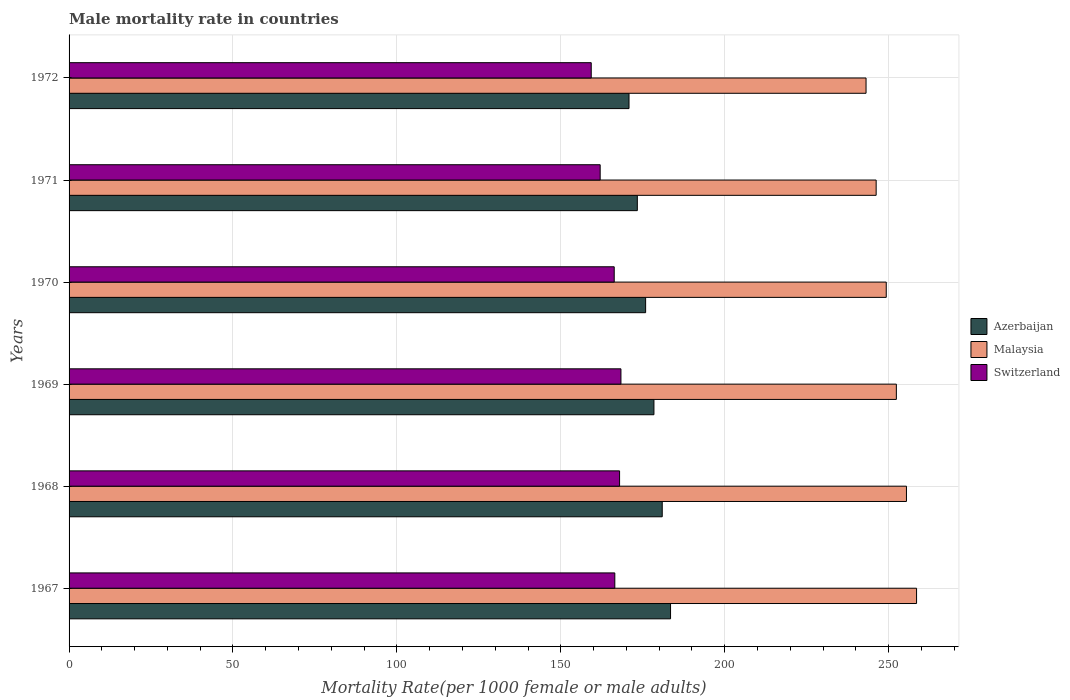How many different coloured bars are there?
Your answer should be very brief. 3. How many groups of bars are there?
Ensure brevity in your answer.  6. Are the number of bars per tick equal to the number of legend labels?
Provide a short and direct response. Yes. How many bars are there on the 5th tick from the top?
Your response must be concise. 3. What is the label of the 5th group of bars from the top?
Give a very brief answer. 1968. In how many cases, is the number of bars for a given year not equal to the number of legend labels?
Your answer should be compact. 0. What is the male mortality rate in Malaysia in 1972?
Keep it short and to the point. 243.12. Across all years, what is the maximum male mortality rate in Azerbaijan?
Make the answer very short. 183.47. Across all years, what is the minimum male mortality rate in Azerbaijan?
Offer a terse response. 170.81. In which year was the male mortality rate in Malaysia maximum?
Keep it short and to the point. 1967. What is the total male mortality rate in Malaysia in the graph?
Provide a succinct answer. 1504.91. What is the difference between the male mortality rate in Switzerland in 1970 and that in 1971?
Your answer should be compact. 4.28. What is the difference between the male mortality rate in Switzerland in 1971 and the male mortality rate in Malaysia in 1967?
Offer a very short reply. -96.51. What is the average male mortality rate in Malaysia per year?
Make the answer very short. 250.82. In the year 1970, what is the difference between the male mortality rate in Switzerland and male mortality rate in Azerbaijan?
Keep it short and to the point. -9.58. In how many years, is the male mortality rate in Malaysia greater than 30 ?
Make the answer very short. 6. What is the ratio of the male mortality rate in Azerbaijan in 1967 to that in 1970?
Make the answer very short. 1.04. Is the difference between the male mortality rate in Switzerland in 1968 and 1969 greater than the difference between the male mortality rate in Azerbaijan in 1968 and 1969?
Give a very brief answer. No. What is the difference between the highest and the second highest male mortality rate in Malaysia?
Make the answer very short. 3.08. What is the difference between the highest and the lowest male mortality rate in Malaysia?
Keep it short and to the point. 15.41. What does the 3rd bar from the top in 1968 represents?
Your answer should be compact. Azerbaijan. What does the 3rd bar from the bottom in 1970 represents?
Your response must be concise. Switzerland. Are all the bars in the graph horizontal?
Your response must be concise. Yes. How many years are there in the graph?
Make the answer very short. 6. Does the graph contain any zero values?
Your answer should be very brief. No. How are the legend labels stacked?
Your answer should be very brief. Vertical. What is the title of the graph?
Your answer should be very brief. Male mortality rate in countries. What is the label or title of the X-axis?
Provide a short and direct response. Mortality Rate(per 1000 female or male adults). What is the label or title of the Y-axis?
Provide a short and direct response. Years. What is the Mortality Rate(per 1000 female or male adults) in Azerbaijan in 1967?
Make the answer very short. 183.47. What is the Mortality Rate(per 1000 female or male adults) of Malaysia in 1967?
Ensure brevity in your answer.  258.52. What is the Mortality Rate(per 1000 female or male adults) in Switzerland in 1967?
Provide a succinct answer. 166.48. What is the Mortality Rate(per 1000 female or male adults) in Azerbaijan in 1968?
Give a very brief answer. 180.94. What is the Mortality Rate(per 1000 female or male adults) in Malaysia in 1968?
Keep it short and to the point. 255.44. What is the Mortality Rate(per 1000 female or male adults) of Switzerland in 1968?
Make the answer very short. 167.93. What is the Mortality Rate(per 1000 female or male adults) in Azerbaijan in 1969?
Ensure brevity in your answer.  178.41. What is the Mortality Rate(per 1000 female or male adults) of Malaysia in 1969?
Offer a very short reply. 252.36. What is the Mortality Rate(per 1000 female or male adults) in Switzerland in 1969?
Provide a succinct answer. 168.34. What is the Mortality Rate(per 1000 female or male adults) in Azerbaijan in 1970?
Offer a terse response. 175.88. What is the Mortality Rate(per 1000 female or male adults) in Malaysia in 1970?
Your response must be concise. 249.28. What is the Mortality Rate(per 1000 female or male adults) in Switzerland in 1970?
Provide a succinct answer. 166.29. What is the Mortality Rate(per 1000 female or male adults) of Azerbaijan in 1971?
Your response must be concise. 173.34. What is the Mortality Rate(per 1000 female or male adults) of Malaysia in 1971?
Provide a short and direct response. 246.2. What is the Mortality Rate(per 1000 female or male adults) of Switzerland in 1971?
Offer a very short reply. 162.01. What is the Mortality Rate(per 1000 female or male adults) of Azerbaijan in 1972?
Your answer should be compact. 170.81. What is the Mortality Rate(per 1000 female or male adults) in Malaysia in 1972?
Make the answer very short. 243.12. What is the Mortality Rate(per 1000 female or male adults) in Switzerland in 1972?
Your answer should be very brief. 159.28. Across all years, what is the maximum Mortality Rate(per 1000 female or male adults) of Azerbaijan?
Offer a terse response. 183.47. Across all years, what is the maximum Mortality Rate(per 1000 female or male adults) of Malaysia?
Ensure brevity in your answer.  258.52. Across all years, what is the maximum Mortality Rate(per 1000 female or male adults) in Switzerland?
Provide a succinct answer. 168.34. Across all years, what is the minimum Mortality Rate(per 1000 female or male adults) of Azerbaijan?
Provide a succinct answer. 170.81. Across all years, what is the minimum Mortality Rate(per 1000 female or male adults) in Malaysia?
Offer a very short reply. 243.12. Across all years, what is the minimum Mortality Rate(per 1000 female or male adults) of Switzerland?
Ensure brevity in your answer.  159.28. What is the total Mortality Rate(per 1000 female or male adults) in Azerbaijan in the graph?
Your response must be concise. 1062.85. What is the total Mortality Rate(per 1000 female or male adults) in Malaysia in the graph?
Keep it short and to the point. 1504.91. What is the total Mortality Rate(per 1000 female or male adults) of Switzerland in the graph?
Your answer should be very brief. 990.34. What is the difference between the Mortality Rate(per 1000 female or male adults) of Azerbaijan in 1967 and that in 1968?
Keep it short and to the point. 2.53. What is the difference between the Mortality Rate(per 1000 female or male adults) in Malaysia in 1967 and that in 1968?
Keep it short and to the point. 3.08. What is the difference between the Mortality Rate(per 1000 female or male adults) of Switzerland in 1967 and that in 1968?
Provide a succinct answer. -1.45. What is the difference between the Mortality Rate(per 1000 female or male adults) of Azerbaijan in 1967 and that in 1969?
Offer a terse response. 5.07. What is the difference between the Mortality Rate(per 1000 female or male adults) in Malaysia in 1967 and that in 1969?
Provide a short and direct response. 6.16. What is the difference between the Mortality Rate(per 1000 female or male adults) of Switzerland in 1967 and that in 1969?
Your answer should be very brief. -1.87. What is the difference between the Mortality Rate(per 1000 female or male adults) in Azerbaijan in 1967 and that in 1970?
Your response must be concise. 7.6. What is the difference between the Mortality Rate(per 1000 female or male adults) in Malaysia in 1967 and that in 1970?
Make the answer very short. 9.24. What is the difference between the Mortality Rate(per 1000 female or male adults) in Switzerland in 1967 and that in 1970?
Your response must be concise. 0.18. What is the difference between the Mortality Rate(per 1000 female or male adults) in Azerbaijan in 1967 and that in 1971?
Make the answer very short. 10.13. What is the difference between the Mortality Rate(per 1000 female or male adults) of Malaysia in 1967 and that in 1971?
Provide a succinct answer. 12.32. What is the difference between the Mortality Rate(per 1000 female or male adults) in Switzerland in 1967 and that in 1971?
Offer a very short reply. 4.46. What is the difference between the Mortality Rate(per 1000 female or male adults) of Azerbaijan in 1967 and that in 1972?
Provide a short and direct response. 12.67. What is the difference between the Mortality Rate(per 1000 female or male adults) in Malaysia in 1967 and that in 1972?
Your answer should be compact. 15.41. What is the difference between the Mortality Rate(per 1000 female or male adults) of Switzerland in 1967 and that in 1972?
Make the answer very short. 7.19. What is the difference between the Mortality Rate(per 1000 female or male adults) in Azerbaijan in 1968 and that in 1969?
Provide a short and direct response. 2.53. What is the difference between the Mortality Rate(per 1000 female or male adults) of Malaysia in 1968 and that in 1969?
Ensure brevity in your answer.  3.08. What is the difference between the Mortality Rate(per 1000 female or male adults) in Switzerland in 1968 and that in 1969?
Make the answer very short. -0.41. What is the difference between the Mortality Rate(per 1000 female or male adults) of Azerbaijan in 1968 and that in 1970?
Offer a very short reply. 5.07. What is the difference between the Mortality Rate(per 1000 female or male adults) in Malaysia in 1968 and that in 1970?
Your answer should be compact. 6.16. What is the difference between the Mortality Rate(per 1000 female or male adults) of Switzerland in 1968 and that in 1970?
Keep it short and to the point. 1.64. What is the difference between the Mortality Rate(per 1000 female or male adults) of Azerbaijan in 1968 and that in 1971?
Make the answer very short. 7.6. What is the difference between the Mortality Rate(per 1000 female or male adults) in Malaysia in 1968 and that in 1971?
Ensure brevity in your answer.  9.24. What is the difference between the Mortality Rate(per 1000 female or male adults) in Switzerland in 1968 and that in 1971?
Give a very brief answer. 5.92. What is the difference between the Mortality Rate(per 1000 female or male adults) of Azerbaijan in 1968 and that in 1972?
Give a very brief answer. 10.13. What is the difference between the Mortality Rate(per 1000 female or male adults) in Malaysia in 1968 and that in 1972?
Offer a terse response. 12.32. What is the difference between the Mortality Rate(per 1000 female or male adults) in Switzerland in 1968 and that in 1972?
Give a very brief answer. 8.65. What is the difference between the Mortality Rate(per 1000 female or male adults) in Azerbaijan in 1969 and that in 1970?
Provide a short and direct response. 2.53. What is the difference between the Mortality Rate(per 1000 female or male adults) in Malaysia in 1969 and that in 1970?
Make the answer very short. 3.08. What is the difference between the Mortality Rate(per 1000 female or male adults) of Switzerland in 1969 and that in 1970?
Provide a short and direct response. 2.05. What is the difference between the Mortality Rate(per 1000 female or male adults) of Azerbaijan in 1969 and that in 1971?
Offer a terse response. 5.07. What is the difference between the Mortality Rate(per 1000 female or male adults) in Malaysia in 1969 and that in 1971?
Make the answer very short. 6.16. What is the difference between the Mortality Rate(per 1000 female or male adults) in Switzerland in 1969 and that in 1971?
Your answer should be compact. 6.33. What is the difference between the Mortality Rate(per 1000 female or male adults) in Azerbaijan in 1969 and that in 1972?
Your response must be concise. 7.6. What is the difference between the Mortality Rate(per 1000 female or male adults) in Malaysia in 1969 and that in 1972?
Your answer should be very brief. 9.24. What is the difference between the Mortality Rate(per 1000 female or male adults) in Switzerland in 1969 and that in 1972?
Provide a succinct answer. 9.06. What is the difference between the Mortality Rate(per 1000 female or male adults) in Azerbaijan in 1970 and that in 1971?
Your answer should be very brief. 2.53. What is the difference between the Mortality Rate(per 1000 female or male adults) in Malaysia in 1970 and that in 1971?
Keep it short and to the point. 3.08. What is the difference between the Mortality Rate(per 1000 female or male adults) in Switzerland in 1970 and that in 1971?
Your answer should be very brief. 4.28. What is the difference between the Mortality Rate(per 1000 female or male adults) of Azerbaijan in 1970 and that in 1972?
Provide a succinct answer. 5.07. What is the difference between the Mortality Rate(per 1000 female or male adults) of Malaysia in 1970 and that in 1972?
Provide a succinct answer. 6.16. What is the difference between the Mortality Rate(per 1000 female or male adults) of Switzerland in 1970 and that in 1972?
Make the answer very short. 7.01. What is the difference between the Mortality Rate(per 1000 female or male adults) of Azerbaijan in 1971 and that in 1972?
Give a very brief answer. 2.53. What is the difference between the Mortality Rate(per 1000 female or male adults) in Malaysia in 1971 and that in 1972?
Provide a succinct answer. 3.08. What is the difference between the Mortality Rate(per 1000 female or male adults) of Switzerland in 1971 and that in 1972?
Offer a very short reply. 2.73. What is the difference between the Mortality Rate(per 1000 female or male adults) in Azerbaijan in 1967 and the Mortality Rate(per 1000 female or male adults) in Malaysia in 1968?
Your answer should be compact. -71.97. What is the difference between the Mortality Rate(per 1000 female or male adults) of Azerbaijan in 1967 and the Mortality Rate(per 1000 female or male adults) of Switzerland in 1968?
Make the answer very short. 15.55. What is the difference between the Mortality Rate(per 1000 female or male adults) in Malaysia in 1967 and the Mortality Rate(per 1000 female or male adults) in Switzerland in 1968?
Provide a short and direct response. 90.59. What is the difference between the Mortality Rate(per 1000 female or male adults) of Azerbaijan in 1967 and the Mortality Rate(per 1000 female or male adults) of Malaysia in 1969?
Make the answer very short. -68.88. What is the difference between the Mortality Rate(per 1000 female or male adults) of Azerbaijan in 1967 and the Mortality Rate(per 1000 female or male adults) of Switzerland in 1969?
Your answer should be very brief. 15.13. What is the difference between the Mortality Rate(per 1000 female or male adults) of Malaysia in 1967 and the Mortality Rate(per 1000 female or male adults) of Switzerland in 1969?
Your response must be concise. 90.18. What is the difference between the Mortality Rate(per 1000 female or male adults) of Azerbaijan in 1967 and the Mortality Rate(per 1000 female or male adults) of Malaysia in 1970?
Keep it short and to the point. -65.8. What is the difference between the Mortality Rate(per 1000 female or male adults) in Azerbaijan in 1967 and the Mortality Rate(per 1000 female or male adults) in Switzerland in 1970?
Offer a very short reply. 17.18. What is the difference between the Mortality Rate(per 1000 female or male adults) of Malaysia in 1967 and the Mortality Rate(per 1000 female or male adults) of Switzerland in 1970?
Provide a short and direct response. 92.23. What is the difference between the Mortality Rate(per 1000 female or male adults) of Azerbaijan in 1967 and the Mortality Rate(per 1000 female or male adults) of Malaysia in 1971?
Your response must be concise. -62.72. What is the difference between the Mortality Rate(per 1000 female or male adults) of Azerbaijan in 1967 and the Mortality Rate(per 1000 female or male adults) of Switzerland in 1971?
Provide a succinct answer. 21.46. What is the difference between the Mortality Rate(per 1000 female or male adults) of Malaysia in 1967 and the Mortality Rate(per 1000 female or male adults) of Switzerland in 1971?
Provide a succinct answer. 96.51. What is the difference between the Mortality Rate(per 1000 female or male adults) in Azerbaijan in 1967 and the Mortality Rate(per 1000 female or male adults) in Malaysia in 1972?
Ensure brevity in your answer.  -59.64. What is the difference between the Mortality Rate(per 1000 female or male adults) in Azerbaijan in 1967 and the Mortality Rate(per 1000 female or male adults) in Switzerland in 1972?
Keep it short and to the point. 24.19. What is the difference between the Mortality Rate(per 1000 female or male adults) of Malaysia in 1967 and the Mortality Rate(per 1000 female or male adults) of Switzerland in 1972?
Your response must be concise. 99.24. What is the difference between the Mortality Rate(per 1000 female or male adults) in Azerbaijan in 1968 and the Mortality Rate(per 1000 female or male adults) in Malaysia in 1969?
Offer a terse response. -71.42. What is the difference between the Mortality Rate(per 1000 female or male adults) of Azerbaijan in 1968 and the Mortality Rate(per 1000 female or male adults) of Switzerland in 1969?
Your response must be concise. 12.6. What is the difference between the Mortality Rate(per 1000 female or male adults) of Malaysia in 1968 and the Mortality Rate(per 1000 female or male adults) of Switzerland in 1969?
Keep it short and to the point. 87.1. What is the difference between the Mortality Rate(per 1000 female or male adults) of Azerbaijan in 1968 and the Mortality Rate(per 1000 female or male adults) of Malaysia in 1970?
Give a very brief answer. -68.34. What is the difference between the Mortality Rate(per 1000 female or male adults) in Azerbaijan in 1968 and the Mortality Rate(per 1000 female or male adults) in Switzerland in 1970?
Offer a terse response. 14.65. What is the difference between the Mortality Rate(per 1000 female or male adults) of Malaysia in 1968 and the Mortality Rate(per 1000 female or male adults) of Switzerland in 1970?
Your answer should be compact. 89.15. What is the difference between the Mortality Rate(per 1000 female or male adults) in Azerbaijan in 1968 and the Mortality Rate(per 1000 female or male adults) in Malaysia in 1971?
Keep it short and to the point. -65.25. What is the difference between the Mortality Rate(per 1000 female or male adults) in Azerbaijan in 1968 and the Mortality Rate(per 1000 female or male adults) in Switzerland in 1971?
Make the answer very short. 18.93. What is the difference between the Mortality Rate(per 1000 female or male adults) of Malaysia in 1968 and the Mortality Rate(per 1000 female or male adults) of Switzerland in 1971?
Ensure brevity in your answer.  93.43. What is the difference between the Mortality Rate(per 1000 female or male adults) in Azerbaijan in 1968 and the Mortality Rate(per 1000 female or male adults) in Malaysia in 1972?
Offer a terse response. -62.17. What is the difference between the Mortality Rate(per 1000 female or male adults) in Azerbaijan in 1968 and the Mortality Rate(per 1000 female or male adults) in Switzerland in 1972?
Provide a short and direct response. 21.66. What is the difference between the Mortality Rate(per 1000 female or male adults) in Malaysia in 1968 and the Mortality Rate(per 1000 female or male adults) in Switzerland in 1972?
Provide a short and direct response. 96.16. What is the difference between the Mortality Rate(per 1000 female or male adults) of Azerbaijan in 1969 and the Mortality Rate(per 1000 female or male adults) of Malaysia in 1970?
Your answer should be compact. -70.87. What is the difference between the Mortality Rate(per 1000 female or male adults) in Azerbaijan in 1969 and the Mortality Rate(per 1000 female or male adults) in Switzerland in 1970?
Give a very brief answer. 12.11. What is the difference between the Mortality Rate(per 1000 female or male adults) of Malaysia in 1969 and the Mortality Rate(per 1000 female or male adults) of Switzerland in 1970?
Provide a succinct answer. 86.06. What is the difference between the Mortality Rate(per 1000 female or male adults) of Azerbaijan in 1969 and the Mortality Rate(per 1000 female or male adults) of Malaysia in 1971?
Ensure brevity in your answer.  -67.79. What is the difference between the Mortality Rate(per 1000 female or male adults) in Azerbaijan in 1969 and the Mortality Rate(per 1000 female or male adults) in Switzerland in 1971?
Ensure brevity in your answer.  16.4. What is the difference between the Mortality Rate(per 1000 female or male adults) in Malaysia in 1969 and the Mortality Rate(per 1000 female or male adults) in Switzerland in 1971?
Give a very brief answer. 90.35. What is the difference between the Mortality Rate(per 1000 female or male adults) in Azerbaijan in 1969 and the Mortality Rate(per 1000 female or male adults) in Malaysia in 1972?
Provide a short and direct response. -64.71. What is the difference between the Mortality Rate(per 1000 female or male adults) of Azerbaijan in 1969 and the Mortality Rate(per 1000 female or male adults) of Switzerland in 1972?
Your answer should be compact. 19.13. What is the difference between the Mortality Rate(per 1000 female or male adults) of Malaysia in 1969 and the Mortality Rate(per 1000 female or male adults) of Switzerland in 1972?
Keep it short and to the point. 93.08. What is the difference between the Mortality Rate(per 1000 female or male adults) of Azerbaijan in 1970 and the Mortality Rate(per 1000 female or male adults) of Malaysia in 1971?
Offer a very short reply. -70.32. What is the difference between the Mortality Rate(per 1000 female or male adults) in Azerbaijan in 1970 and the Mortality Rate(per 1000 female or male adults) in Switzerland in 1971?
Ensure brevity in your answer.  13.86. What is the difference between the Mortality Rate(per 1000 female or male adults) in Malaysia in 1970 and the Mortality Rate(per 1000 female or male adults) in Switzerland in 1971?
Provide a short and direct response. 87.27. What is the difference between the Mortality Rate(per 1000 female or male adults) of Azerbaijan in 1970 and the Mortality Rate(per 1000 female or male adults) of Malaysia in 1972?
Keep it short and to the point. -67.24. What is the difference between the Mortality Rate(per 1000 female or male adults) in Azerbaijan in 1970 and the Mortality Rate(per 1000 female or male adults) in Switzerland in 1972?
Your answer should be very brief. 16.59. What is the difference between the Mortality Rate(per 1000 female or male adults) in Malaysia in 1970 and the Mortality Rate(per 1000 female or male adults) in Switzerland in 1972?
Ensure brevity in your answer.  89.99. What is the difference between the Mortality Rate(per 1000 female or male adults) in Azerbaijan in 1971 and the Mortality Rate(per 1000 female or male adults) in Malaysia in 1972?
Your response must be concise. -69.77. What is the difference between the Mortality Rate(per 1000 female or male adults) in Azerbaijan in 1971 and the Mortality Rate(per 1000 female or male adults) in Switzerland in 1972?
Ensure brevity in your answer.  14.06. What is the difference between the Mortality Rate(per 1000 female or male adults) in Malaysia in 1971 and the Mortality Rate(per 1000 female or male adults) in Switzerland in 1972?
Ensure brevity in your answer.  86.91. What is the average Mortality Rate(per 1000 female or male adults) of Azerbaijan per year?
Ensure brevity in your answer.  177.14. What is the average Mortality Rate(per 1000 female or male adults) in Malaysia per year?
Your answer should be very brief. 250.82. What is the average Mortality Rate(per 1000 female or male adults) in Switzerland per year?
Provide a short and direct response. 165.06. In the year 1967, what is the difference between the Mortality Rate(per 1000 female or male adults) in Azerbaijan and Mortality Rate(per 1000 female or male adults) in Malaysia?
Keep it short and to the point. -75.05. In the year 1967, what is the difference between the Mortality Rate(per 1000 female or male adults) of Azerbaijan and Mortality Rate(per 1000 female or male adults) of Switzerland?
Give a very brief answer. 17. In the year 1967, what is the difference between the Mortality Rate(per 1000 female or male adults) in Malaysia and Mortality Rate(per 1000 female or male adults) in Switzerland?
Your response must be concise. 92.05. In the year 1968, what is the difference between the Mortality Rate(per 1000 female or male adults) of Azerbaijan and Mortality Rate(per 1000 female or male adults) of Malaysia?
Your answer should be compact. -74.5. In the year 1968, what is the difference between the Mortality Rate(per 1000 female or male adults) in Azerbaijan and Mortality Rate(per 1000 female or male adults) in Switzerland?
Your answer should be compact. 13.01. In the year 1968, what is the difference between the Mortality Rate(per 1000 female or male adults) of Malaysia and Mortality Rate(per 1000 female or male adults) of Switzerland?
Provide a short and direct response. 87.51. In the year 1969, what is the difference between the Mortality Rate(per 1000 female or male adults) in Azerbaijan and Mortality Rate(per 1000 female or male adults) in Malaysia?
Offer a terse response. -73.95. In the year 1969, what is the difference between the Mortality Rate(per 1000 female or male adults) of Azerbaijan and Mortality Rate(per 1000 female or male adults) of Switzerland?
Offer a terse response. 10.07. In the year 1969, what is the difference between the Mortality Rate(per 1000 female or male adults) of Malaysia and Mortality Rate(per 1000 female or male adults) of Switzerland?
Keep it short and to the point. 84.02. In the year 1970, what is the difference between the Mortality Rate(per 1000 female or male adults) of Azerbaijan and Mortality Rate(per 1000 female or male adults) of Malaysia?
Provide a short and direct response. -73.4. In the year 1970, what is the difference between the Mortality Rate(per 1000 female or male adults) of Azerbaijan and Mortality Rate(per 1000 female or male adults) of Switzerland?
Offer a very short reply. 9.58. In the year 1970, what is the difference between the Mortality Rate(per 1000 female or male adults) in Malaysia and Mortality Rate(per 1000 female or male adults) in Switzerland?
Your answer should be compact. 82.98. In the year 1971, what is the difference between the Mortality Rate(per 1000 female or male adults) of Azerbaijan and Mortality Rate(per 1000 female or male adults) of Malaysia?
Offer a very short reply. -72.85. In the year 1971, what is the difference between the Mortality Rate(per 1000 female or male adults) in Azerbaijan and Mortality Rate(per 1000 female or male adults) in Switzerland?
Your answer should be very brief. 11.33. In the year 1971, what is the difference between the Mortality Rate(per 1000 female or male adults) in Malaysia and Mortality Rate(per 1000 female or male adults) in Switzerland?
Give a very brief answer. 84.19. In the year 1972, what is the difference between the Mortality Rate(per 1000 female or male adults) in Azerbaijan and Mortality Rate(per 1000 female or male adults) in Malaysia?
Your answer should be compact. -72.31. In the year 1972, what is the difference between the Mortality Rate(per 1000 female or male adults) in Azerbaijan and Mortality Rate(per 1000 female or male adults) in Switzerland?
Offer a very short reply. 11.53. In the year 1972, what is the difference between the Mortality Rate(per 1000 female or male adults) of Malaysia and Mortality Rate(per 1000 female or male adults) of Switzerland?
Offer a terse response. 83.83. What is the ratio of the Mortality Rate(per 1000 female or male adults) in Malaysia in 1967 to that in 1968?
Provide a short and direct response. 1.01. What is the ratio of the Mortality Rate(per 1000 female or male adults) of Switzerland in 1967 to that in 1968?
Your answer should be compact. 0.99. What is the ratio of the Mortality Rate(per 1000 female or male adults) in Azerbaijan in 1967 to that in 1969?
Your answer should be very brief. 1.03. What is the ratio of the Mortality Rate(per 1000 female or male adults) of Malaysia in 1967 to that in 1969?
Offer a very short reply. 1.02. What is the ratio of the Mortality Rate(per 1000 female or male adults) of Switzerland in 1967 to that in 1969?
Provide a short and direct response. 0.99. What is the ratio of the Mortality Rate(per 1000 female or male adults) in Azerbaijan in 1967 to that in 1970?
Your response must be concise. 1.04. What is the ratio of the Mortality Rate(per 1000 female or male adults) of Malaysia in 1967 to that in 1970?
Your answer should be very brief. 1.04. What is the ratio of the Mortality Rate(per 1000 female or male adults) in Switzerland in 1967 to that in 1970?
Give a very brief answer. 1. What is the ratio of the Mortality Rate(per 1000 female or male adults) of Azerbaijan in 1967 to that in 1971?
Your answer should be compact. 1.06. What is the ratio of the Mortality Rate(per 1000 female or male adults) of Malaysia in 1967 to that in 1971?
Ensure brevity in your answer.  1.05. What is the ratio of the Mortality Rate(per 1000 female or male adults) in Switzerland in 1967 to that in 1971?
Offer a terse response. 1.03. What is the ratio of the Mortality Rate(per 1000 female or male adults) in Azerbaijan in 1967 to that in 1972?
Give a very brief answer. 1.07. What is the ratio of the Mortality Rate(per 1000 female or male adults) of Malaysia in 1967 to that in 1972?
Your response must be concise. 1.06. What is the ratio of the Mortality Rate(per 1000 female or male adults) in Switzerland in 1967 to that in 1972?
Make the answer very short. 1.05. What is the ratio of the Mortality Rate(per 1000 female or male adults) in Azerbaijan in 1968 to that in 1969?
Your response must be concise. 1.01. What is the ratio of the Mortality Rate(per 1000 female or male adults) of Malaysia in 1968 to that in 1969?
Ensure brevity in your answer.  1.01. What is the ratio of the Mortality Rate(per 1000 female or male adults) in Azerbaijan in 1968 to that in 1970?
Your answer should be very brief. 1.03. What is the ratio of the Mortality Rate(per 1000 female or male adults) in Malaysia in 1968 to that in 1970?
Offer a very short reply. 1.02. What is the ratio of the Mortality Rate(per 1000 female or male adults) in Switzerland in 1968 to that in 1970?
Offer a very short reply. 1.01. What is the ratio of the Mortality Rate(per 1000 female or male adults) in Azerbaijan in 1968 to that in 1971?
Provide a short and direct response. 1.04. What is the ratio of the Mortality Rate(per 1000 female or male adults) in Malaysia in 1968 to that in 1971?
Offer a very short reply. 1.04. What is the ratio of the Mortality Rate(per 1000 female or male adults) in Switzerland in 1968 to that in 1971?
Make the answer very short. 1.04. What is the ratio of the Mortality Rate(per 1000 female or male adults) in Azerbaijan in 1968 to that in 1972?
Provide a short and direct response. 1.06. What is the ratio of the Mortality Rate(per 1000 female or male adults) of Malaysia in 1968 to that in 1972?
Your answer should be very brief. 1.05. What is the ratio of the Mortality Rate(per 1000 female or male adults) of Switzerland in 1968 to that in 1972?
Your answer should be compact. 1.05. What is the ratio of the Mortality Rate(per 1000 female or male adults) of Azerbaijan in 1969 to that in 1970?
Provide a short and direct response. 1.01. What is the ratio of the Mortality Rate(per 1000 female or male adults) in Malaysia in 1969 to that in 1970?
Provide a succinct answer. 1.01. What is the ratio of the Mortality Rate(per 1000 female or male adults) of Switzerland in 1969 to that in 1970?
Ensure brevity in your answer.  1.01. What is the ratio of the Mortality Rate(per 1000 female or male adults) in Azerbaijan in 1969 to that in 1971?
Make the answer very short. 1.03. What is the ratio of the Mortality Rate(per 1000 female or male adults) in Malaysia in 1969 to that in 1971?
Your answer should be compact. 1.02. What is the ratio of the Mortality Rate(per 1000 female or male adults) in Switzerland in 1969 to that in 1971?
Your answer should be very brief. 1.04. What is the ratio of the Mortality Rate(per 1000 female or male adults) in Azerbaijan in 1969 to that in 1972?
Offer a terse response. 1.04. What is the ratio of the Mortality Rate(per 1000 female or male adults) in Malaysia in 1969 to that in 1972?
Keep it short and to the point. 1.04. What is the ratio of the Mortality Rate(per 1000 female or male adults) of Switzerland in 1969 to that in 1972?
Offer a terse response. 1.06. What is the ratio of the Mortality Rate(per 1000 female or male adults) of Azerbaijan in 1970 to that in 1971?
Keep it short and to the point. 1.01. What is the ratio of the Mortality Rate(per 1000 female or male adults) of Malaysia in 1970 to that in 1971?
Your answer should be compact. 1.01. What is the ratio of the Mortality Rate(per 1000 female or male adults) of Switzerland in 1970 to that in 1971?
Your answer should be very brief. 1.03. What is the ratio of the Mortality Rate(per 1000 female or male adults) of Azerbaijan in 1970 to that in 1972?
Provide a succinct answer. 1.03. What is the ratio of the Mortality Rate(per 1000 female or male adults) in Malaysia in 1970 to that in 1972?
Offer a terse response. 1.03. What is the ratio of the Mortality Rate(per 1000 female or male adults) in Switzerland in 1970 to that in 1972?
Offer a very short reply. 1.04. What is the ratio of the Mortality Rate(per 1000 female or male adults) in Azerbaijan in 1971 to that in 1972?
Your answer should be compact. 1.01. What is the ratio of the Mortality Rate(per 1000 female or male adults) in Malaysia in 1971 to that in 1972?
Provide a short and direct response. 1.01. What is the ratio of the Mortality Rate(per 1000 female or male adults) of Switzerland in 1971 to that in 1972?
Make the answer very short. 1.02. What is the difference between the highest and the second highest Mortality Rate(per 1000 female or male adults) in Azerbaijan?
Offer a very short reply. 2.53. What is the difference between the highest and the second highest Mortality Rate(per 1000 female or male adults) in Malaysia?
Your answer should be very brief. 3.08. What is the difference between the highest and the second highest Mortality Rate(per 1000 female or male adults) of Switzerland?
Ensure brevity in your answer.  0.41. What is the difference between the highest and the lowest Mortality Rate(per 1000 female or male adults) of Azerbaijan?
Your answer should be very brief. 12.67. What is the difference between the highest and the lowest Mortality Rate(per 1000 female or male adults) in Malaysia?
Give a very brief answer. 15.41. What is the difference between the highest and the lowest Mortality Rate(per 1000 female or male adults) of Switzerland?
Your answer should be very brief. 9.06. 